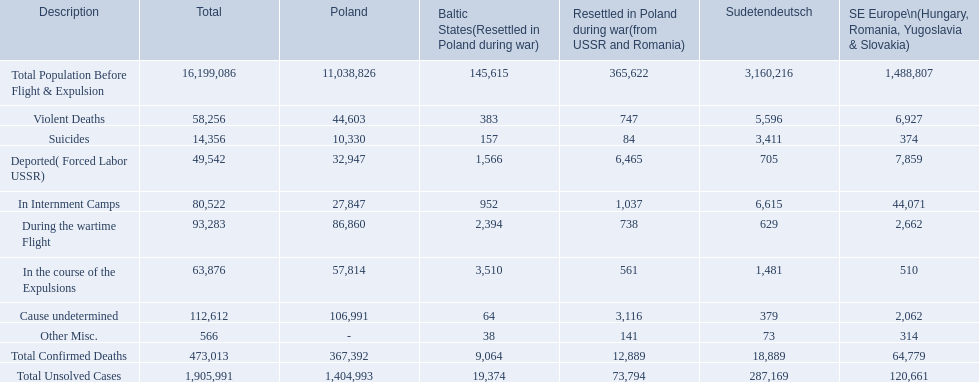How many total confirmed deaths were there in the baltic states? 9,064. How many deaths had an undetermined cause? 64. How many deaths in that region were miscellaneous? 38. Were there more deaths from an undetermined cause or that were listed as miscellaneous? Cause undetermined. What is the number of fatalities in each category for the baltic states? 145,615, 383, 157, 1,566, 952, 2,394, 3,510, 64, 38, 9,064, 19,374. How many deaths with uncertain causes occurred in the baltic states? 64. How many additional miscellaneous deaths took place in the baltic states? 38. Which category has a higher death count, uncertain causes or miscellaneous? Cause undetermined. What is the number of fatalities in each category for the baltic states? 145,615, 383, 157, 1,566, 952, 2,394, 3,510, 64, 38, 9,064, 19,374. How many deaths in the baltic states have an undetermined cause? 64. How many other miscellaneous deaths occurred in the baltic states? 38. Which category has a higher death count: undetermined cause or other miscellaneous? Cause undetermined. 